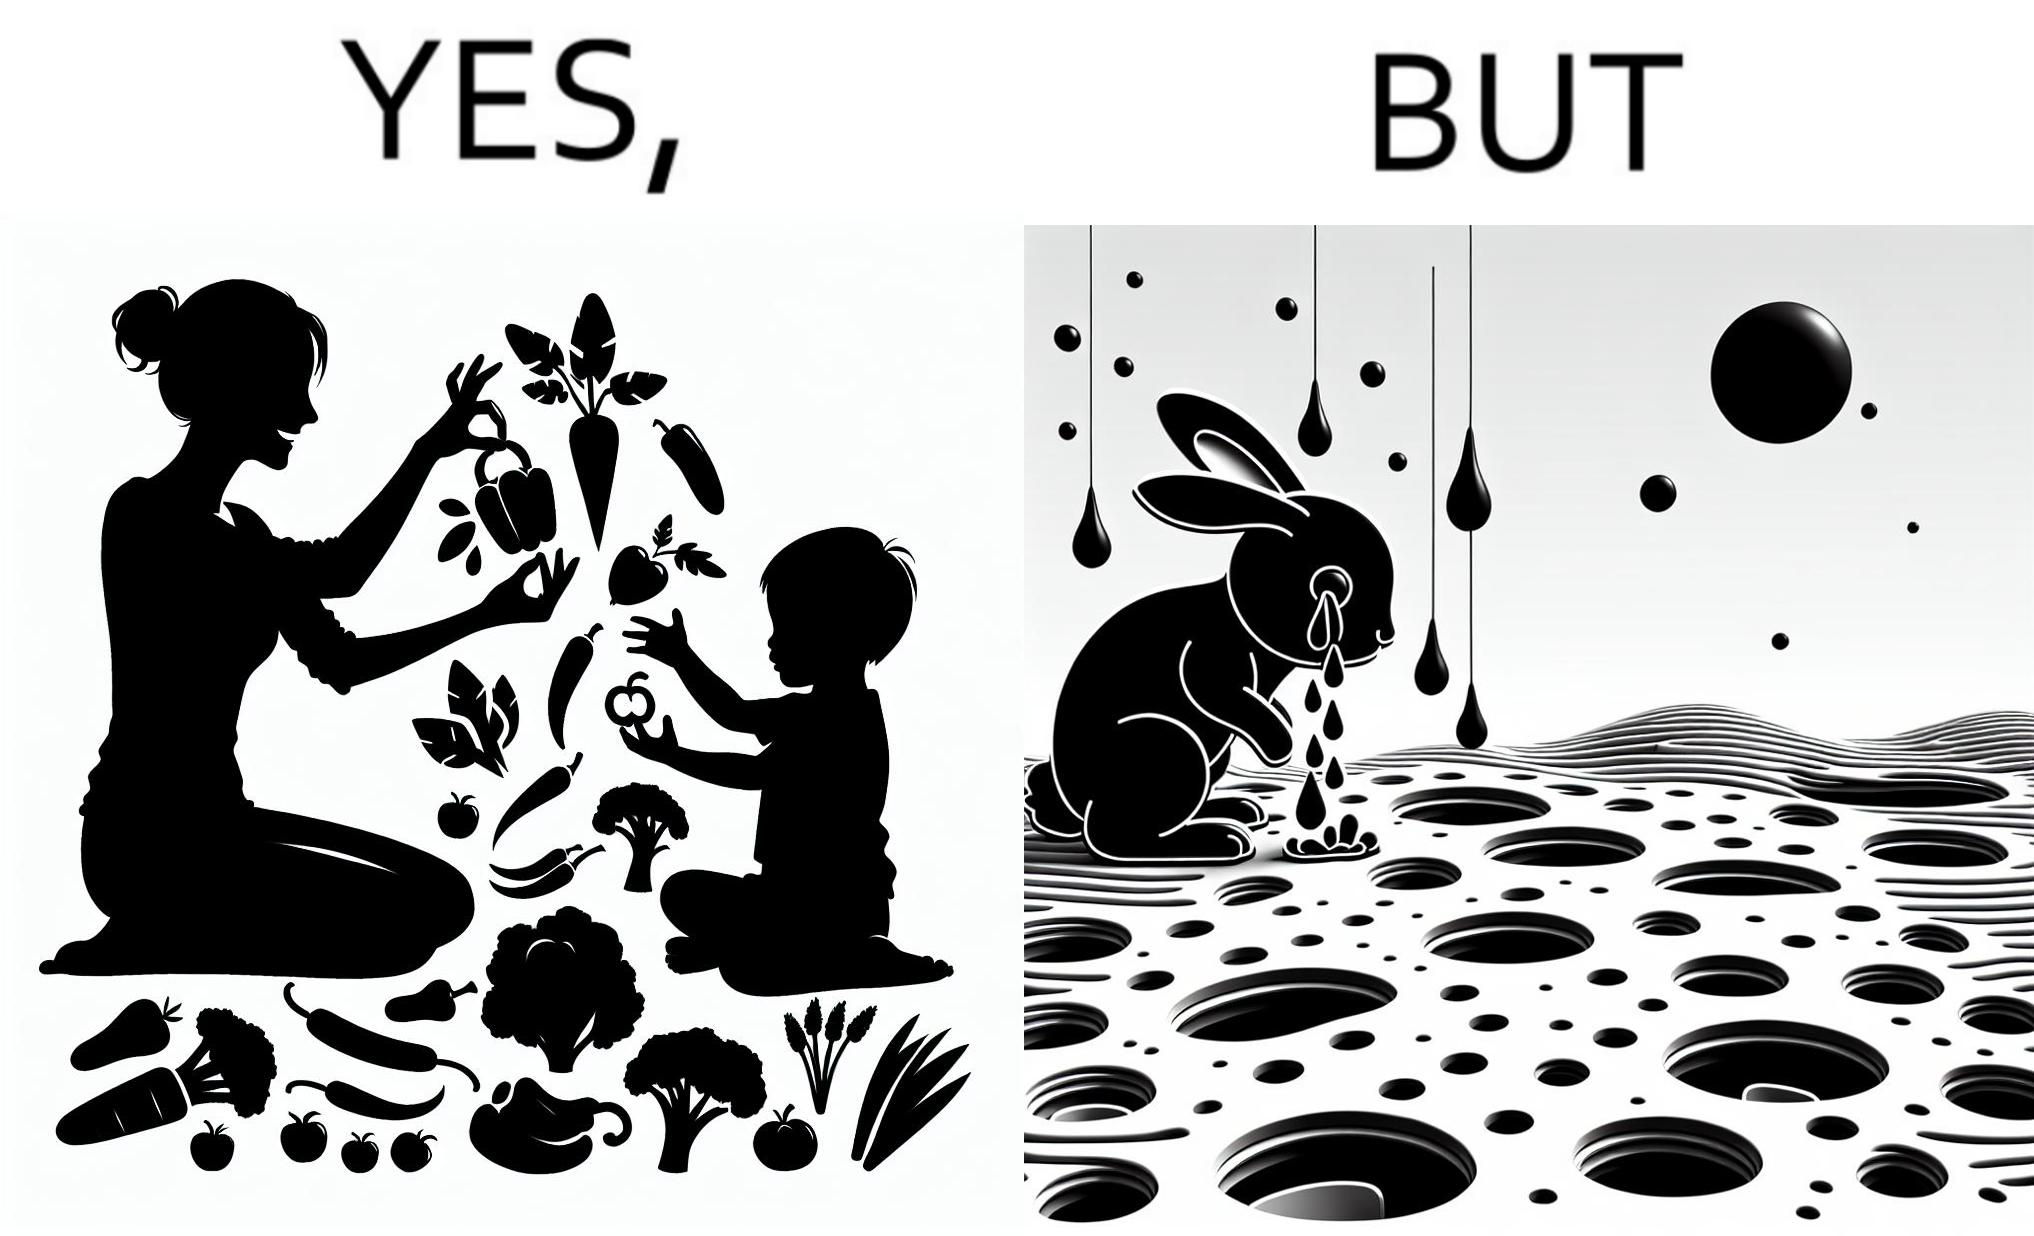Describe the satirical element in this image. The images are ironic since they show how on one hand humans choose to play with and waste foods like vegetables while the animals are unable to eat enough food and end up starving due to lack of food 